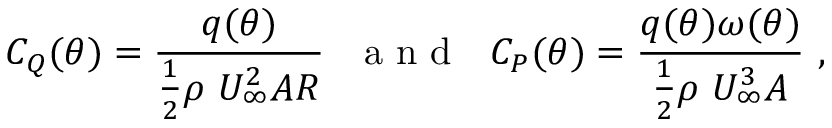Convert formula to latex. <formula><loc_0><loc_0><loc_500><loc_500>C _ { Q } ( \theta ) = \frac { q ( \theta ) } { \frac { 1 } { 2 } \rho \ U _ { \infty } ^ { 2 } A R } \ \ a n d \ \ C _ { P } ( \theta ) = \frac { q ( \theta ) \omega ( \theta ) } { \frac { 1 } { 2 } \rho \ U _ { \infty } ^ { 3 } A } \ ,</formula> 